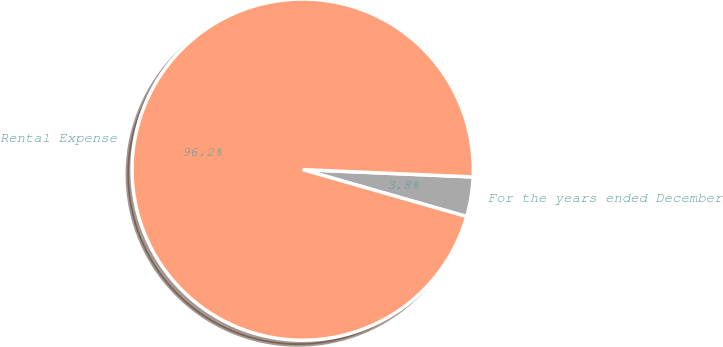<chart> <loc_0><loc_0><loc_500><loc_500><pie_chart><fcel>For the years ended December<fcel>Rental Expense<nl><fcel>3.75%<fcel>96.25%<nl></chart> 